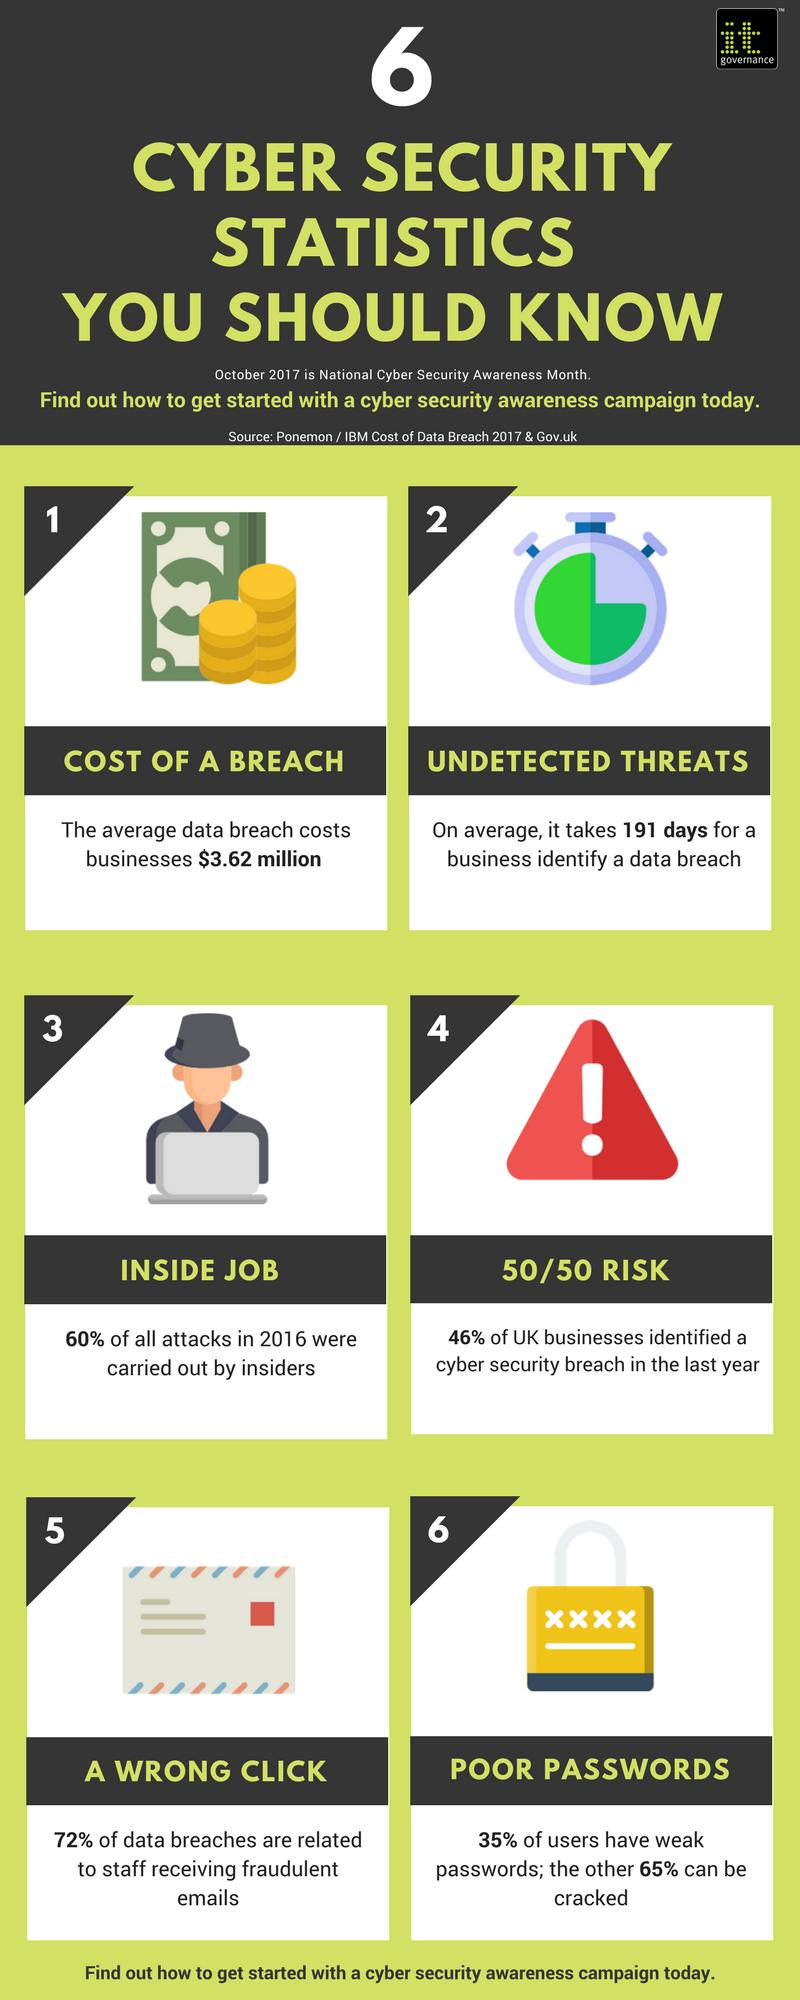Identify some key points in this picture. On average, businesses take 191 days to identify undetected threats. According to a recent study, 72% of data breaches were caused by fraudulent emails. A significant portion, approximately 60%, of cyber attacks originate from within an organization itself. In the last year, 54% of UK businesses did not experience a cyber security breach. The color of the exclamation mark within the triangle in the fourth image is white. 